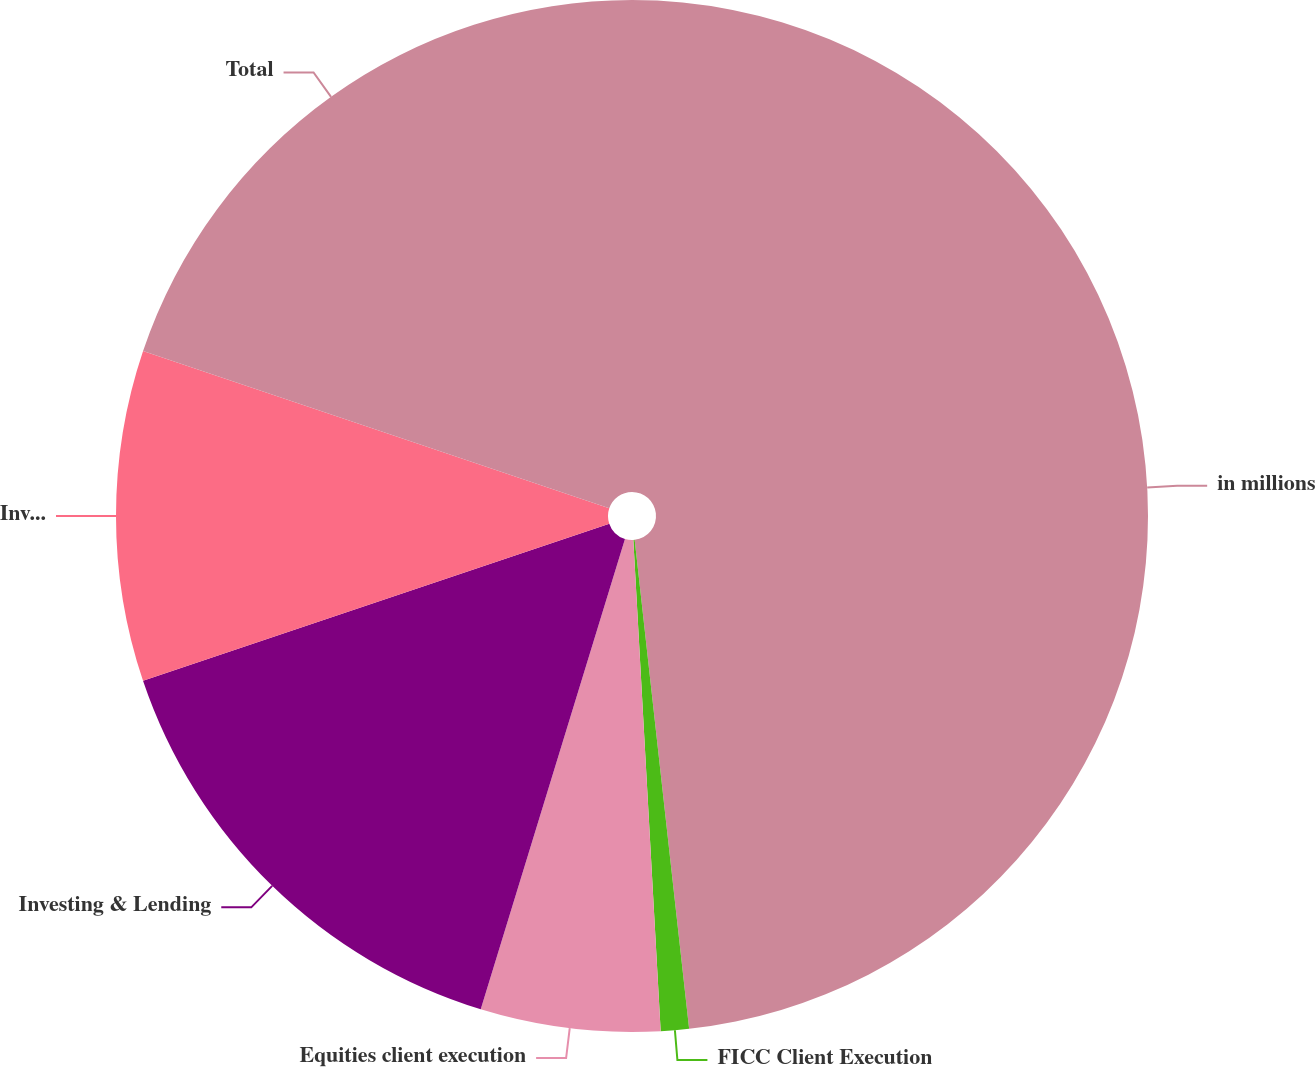Convert chart to OTSL. <chart><loc_0><loc_0><loc_500><loc_500><pie_chart><fcel>in millions<fcel>FICC Client Execution<fcel>Equities client execution<fcel>Investing & Lending<fcel>Investment Management<fcel>Total<nl><fcel>48.23%<fcel>0.88%<fcel>5.62%<fcel>15.09%<fcel>10.35%<fcel>19.82%<nl></chart> 